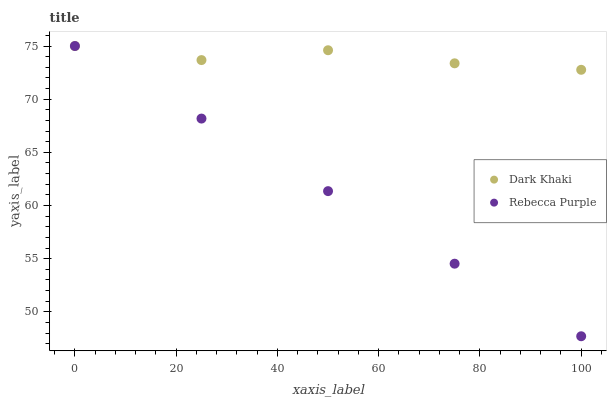Does Rebecca Purple have the minimum area under the curve?
Answer yes or no. Yes. Does Dark Khaki have the maximum area under the curve?
Answer yes or no. Yes. Does Rebecca Purple have the maximum area under the curve?
Answer yes or no. No. Is Rebecca Purple the smoothest?
Answer yes or no. Yes. Is Dark Khaki the roughest?
Answer yes or no. Yes. Is Rebecca Purple the roughest?
Answer yes or no. No. Does Rebecca Purple have the lowest value?
Answer yes or no. Yes. Does Rebecca Purple have the highest value?
Answer yes or no. Yes. Does Dark Khaki intersect Rebecca Purple?
Answer yes or no. Yes. Is Dark Khaki less than Rebecca Purple?
Answer yes or no. No. Is Dark Khaki greater than Rebecca Purple?
Answer yes or no. No. 